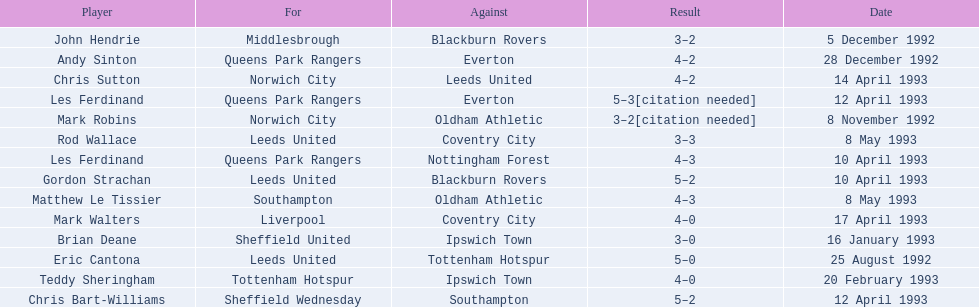Name the players for tottenham hotspur. Teddy Sheringham. Parse the table in full. {'header': ['Player', 'For', 'Against', 'Result', 'Date'], 'rows': [['John Hendrie', 'Middlesbrough', 'Blackburn Rovers', '3–2', '5 December 1992'], ['Andy Sinton', 'Queens Park Rangers', 'Everton', '4–2', '28 December 1992'], ['Chris Sutton', 'Norwich City', 'Leeds United', '4–2', '14 April 1993'], ['Les Ferdinand', 'Queens Park Rangers', 'Everton', '5–3[citation needed]', '12 April 1993'], ['Mark Robins', 'Norwich City', 'Oldham Athletic', '3–2[citation needed]', '8 November 1992'], ['Rod Wallace', 'Leeds United', 'Coventry City', '3–3', '8 May 1993'], ['Les Ferdinand', 'Queens Park Rangers', 'Nottingham Forest', '4–3', '10 April 1993'], ['Gordon Strachan', 'Leeds United', 'Blackburn Rovers', '5–2', '10 April 1993'], ['Matthew Le Tissier', 'Southampton', 'Oldham Athletic', '4–3', '8 May 1993'], ['Mark Walters', 'Liverpool', 'Coventry City', '4–0', '17 April 1993'], ['Brian Deane', 'Sheffield United', 'Ipswich Town', '3–0', '16 January 1993'], ['Eric Cantona', 'Leeds United', 'Tottenham Hotspur', '5–0', '25 August 1992'], ['Teddy Sheringham', 'Tottenham Hotspur', 'Ipswich Town', '4–0', '20 February 1993'], ['Chris Bart-Williams', 'Sheffield Wednesday', 'Southampton', '5–2', '12 April 1993']]} 